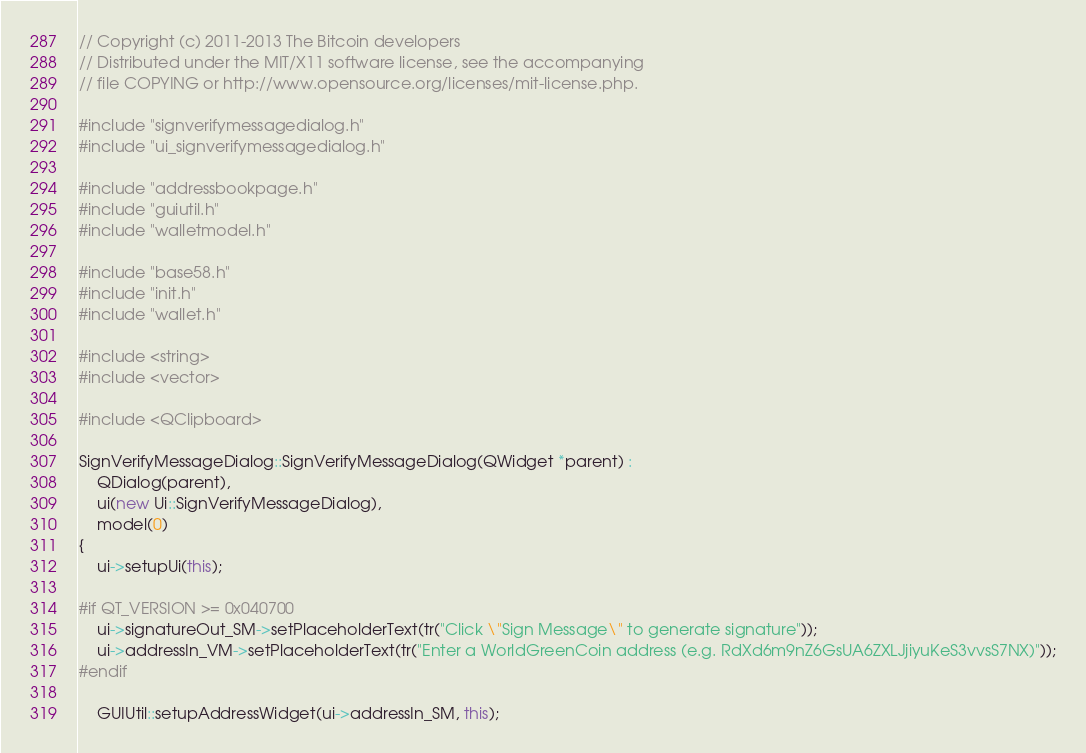<code> <loc_0><loc_0><loc_500><loc_500><_C++_>// Copyright (c) 2011-2013 The Bitcoin developers
// Distributed under the MIT/X11 software license, see the accompanying
// file COPYING or http://www.opensource.org/licenses/mit-license.php.

#include "signverifymessagedialog.h"
#include "ui_signverifymessagedialog.h"

#include "addressbookpage.h"
#include "guiutil.h"
#include "walletmodel.h"

#include "base58.h"
#include "init.h"
#include "wallet.h"

#include <string>
#include <vector>

#include <QClipboard>

SignVerifyMessageDialog::SignVerifyMessageDialog(QWidget *parent) :
    QDialog(parent),
    ui(new Ui::SignVerifyMessageDialog),
    model(0)
{
    ui->setupUi(this);

#if QT_VERSION >= 0x040700
    ui->signatureOut_SM->setPlaceholderText(tr("Click \"Sign Message\" to generate signature"));
    ui->addressIn_VM->setPlaceholderText(tr("Enter a WorldGreenCoin address (e.g. RdXd6m9nZ6GsUA6ZXLJjiyuKeS3vvsS7NX)"));
#endif

    GUIUtil::setupAddressWidget(ui->addressIn_SM, this);</code> 